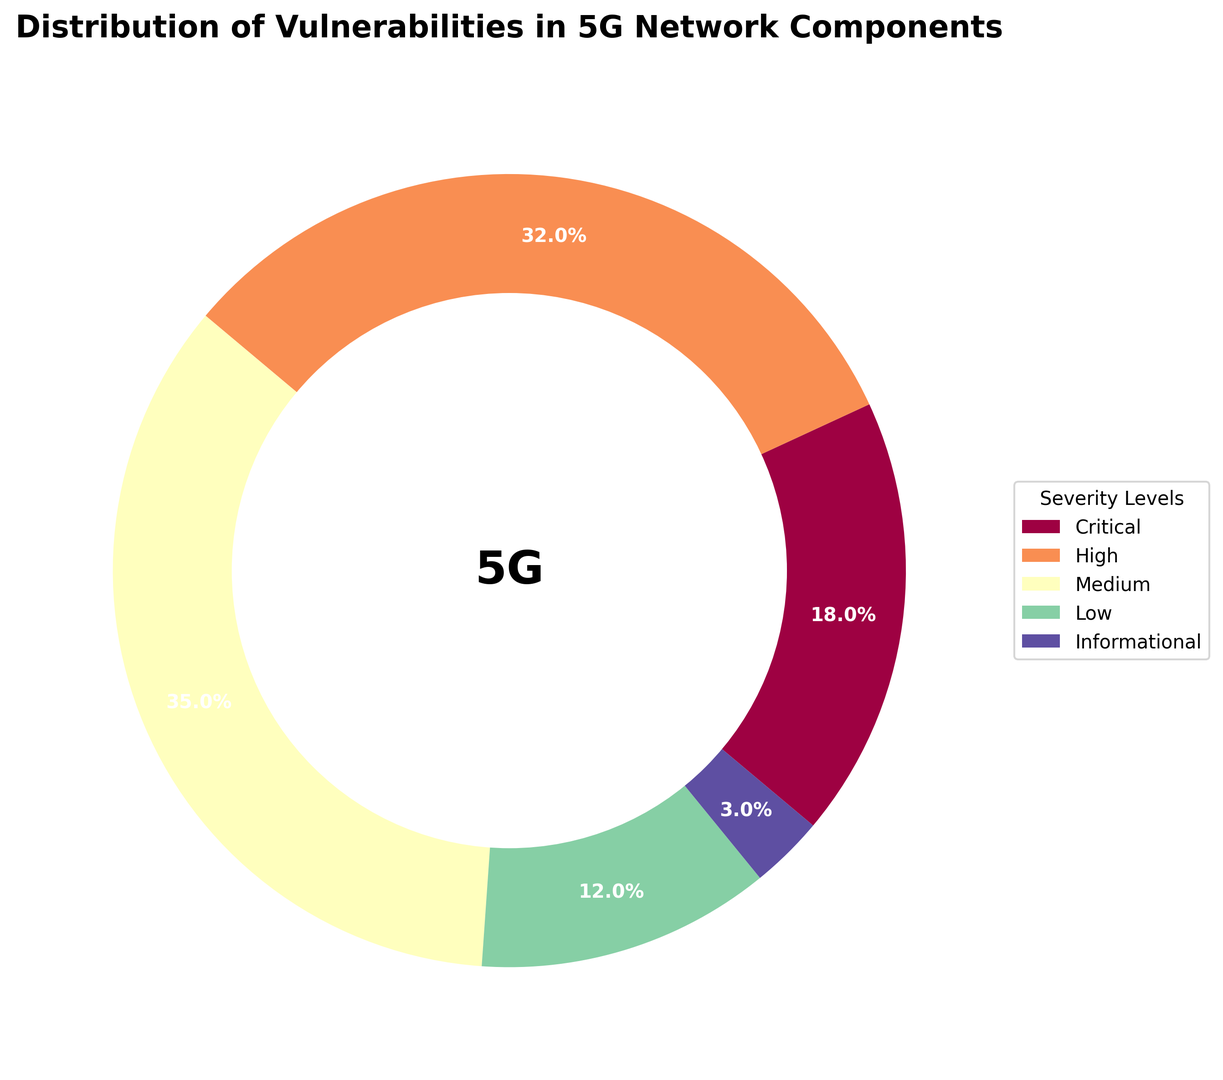What percentage of vulnerabilities are critical? To determine this, refer to the segment labeled "Critical" on the ring chart. The figure shows that this segment corresponds to 18%, as indicated by the label on the chart.
Answer: 18% Which severity level has the highest percentage of vulnerabilities? To find this, look at all the segments on the chart and identify the one with the largest percentage value. The "Medium" severity level has the highest percentage, which is 35%, clearly shown on the chart.
Answer: Medium What is the combined percentage of High and Medium severity vulnerabilities? First, identify the percentage values for High (32%) and Medium (35%) from the chart. Then add these values together: 32% + 35% = 67%.
Answer: 67% Which severity level has the smallest percentage of vulnerabilities, and what is that percentage? Locate the smallest percentage value on the chart. The "Informational" segment has the smallest percentage, which is 3%, as shown.
Answer: Informational, 3% How does the percentage of Low severity vulnerabilities compare to Critical severity vulnerabilities? Check the percentages for Low and Critical categories: Low is 12% and Critical is 18%. Low severity vulnerabilities have a smaller percentage than Critical severity vulnerabilities.
Answer: Low is less than Critical What is the difference in percentage between Medium and Low severity vulnerabilities? Identify the percentages for Medium (35%) and Low (12%) from the chart. Subtract the smaller value from the larger one: 35% - 12% = 23%.
Answer: 23% Is the visualization symmetrical? Observe the distribution of segments around the ring. Because the segments are of varying sizes and not evenly spaced, the visualization is not symmetrical.
Answer: No What color represents High severity vulnerabilities? Identify the segment labeled "High" and note its color. The segment labeled "High" is represented by a shade of orange.
Answer: Orange What percentage of vulnerabilities are either Critical or Low? Add the percentages for Critical (18%) and Low (12%) severity levels: 18% + 12% = 30%.
Answer: 30% What percentage is neither Medium nor High severity vulnerabilities? Calculate the percentage for Medium and High (35% + 32% = 67%). Subtract this from 100% to find the percentage of other categories: 100% - 67% = 33%.
Answer: 33% 